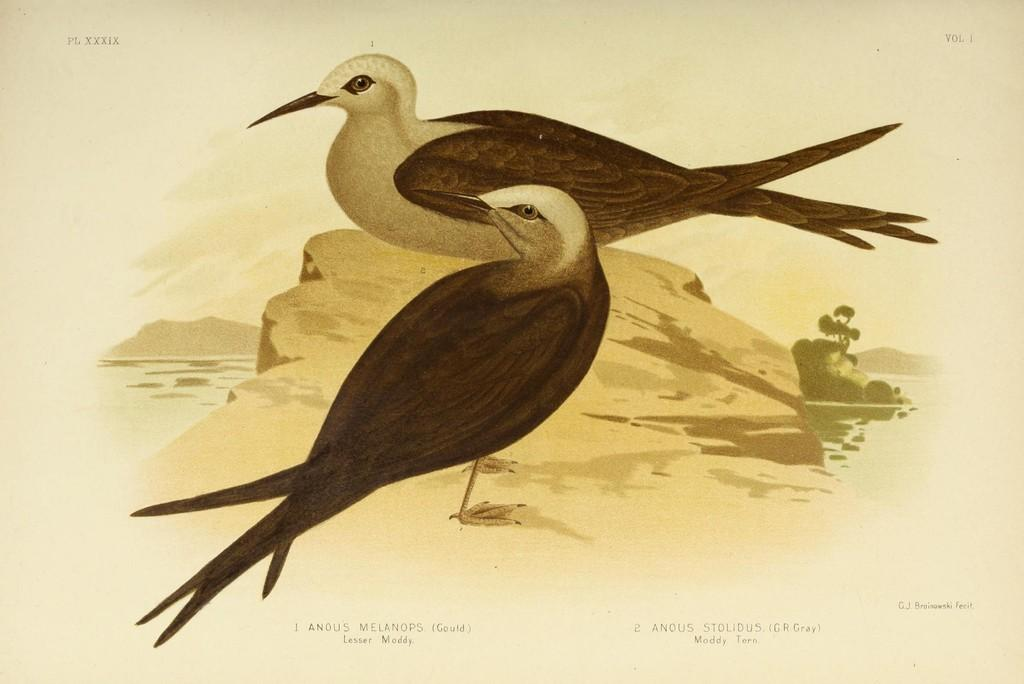What is depicted in the painting in the image? There is a painting of two birds on a rock in the image. What natural element can be seen in the image besides the painting? There is water visible in the image. What type of vegetation is present in the image? There are trees in the image. What geographical feature can be seen in the image? There are mountains in the image. What part of the natural environment is visible in the image? The sky is visible in the image. Are there any imperfections or marks on the image? Yes, there are watermarks on the image. What is the name of the daughter of the tree in the image? There is no daughter mentioned in the image, as trees do not have children. 